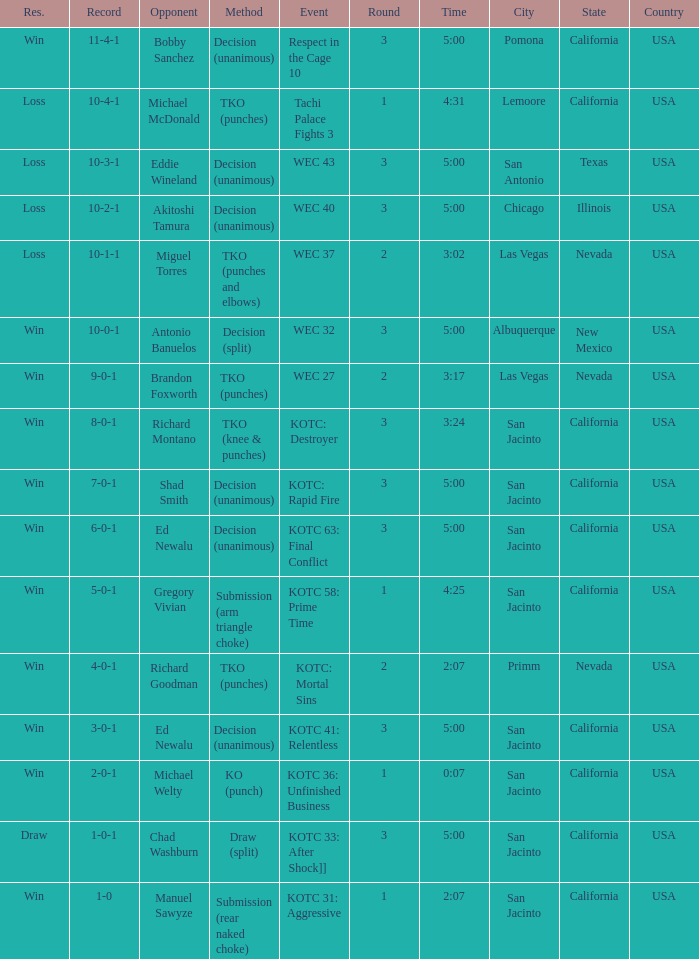What location did the event kotc: mortal sins take place? Primm, Nevada , USA. 